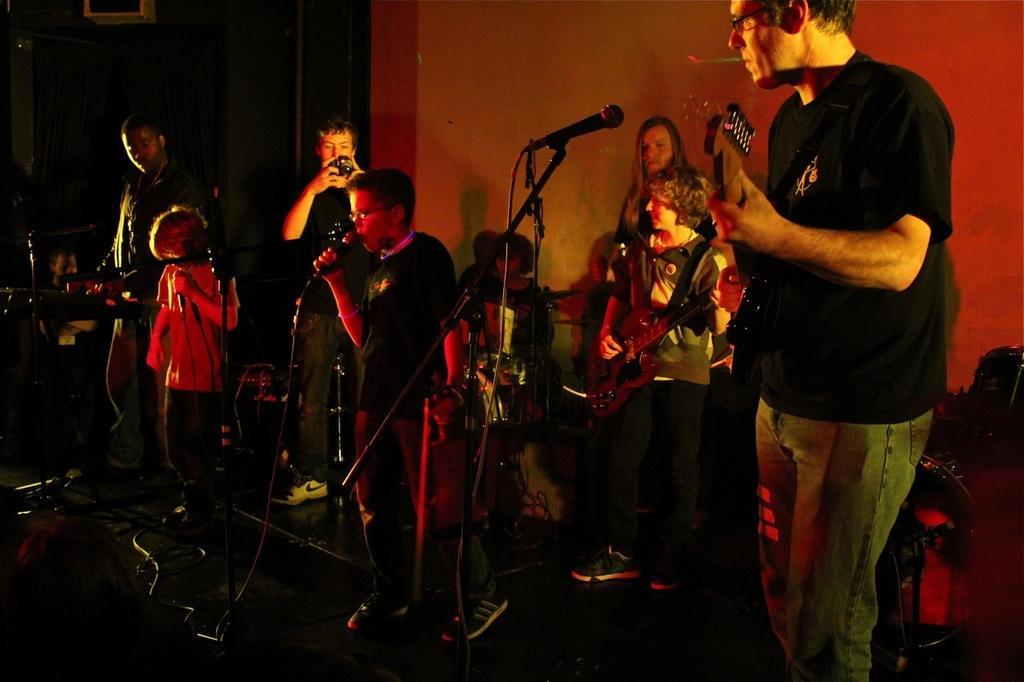In one or two sentences, can you explain what this image depicts? In this image I see people who are standing and few of them are holding guitars and few of them are holdings mics and this man is holding a camera. In the background I see the wall. 